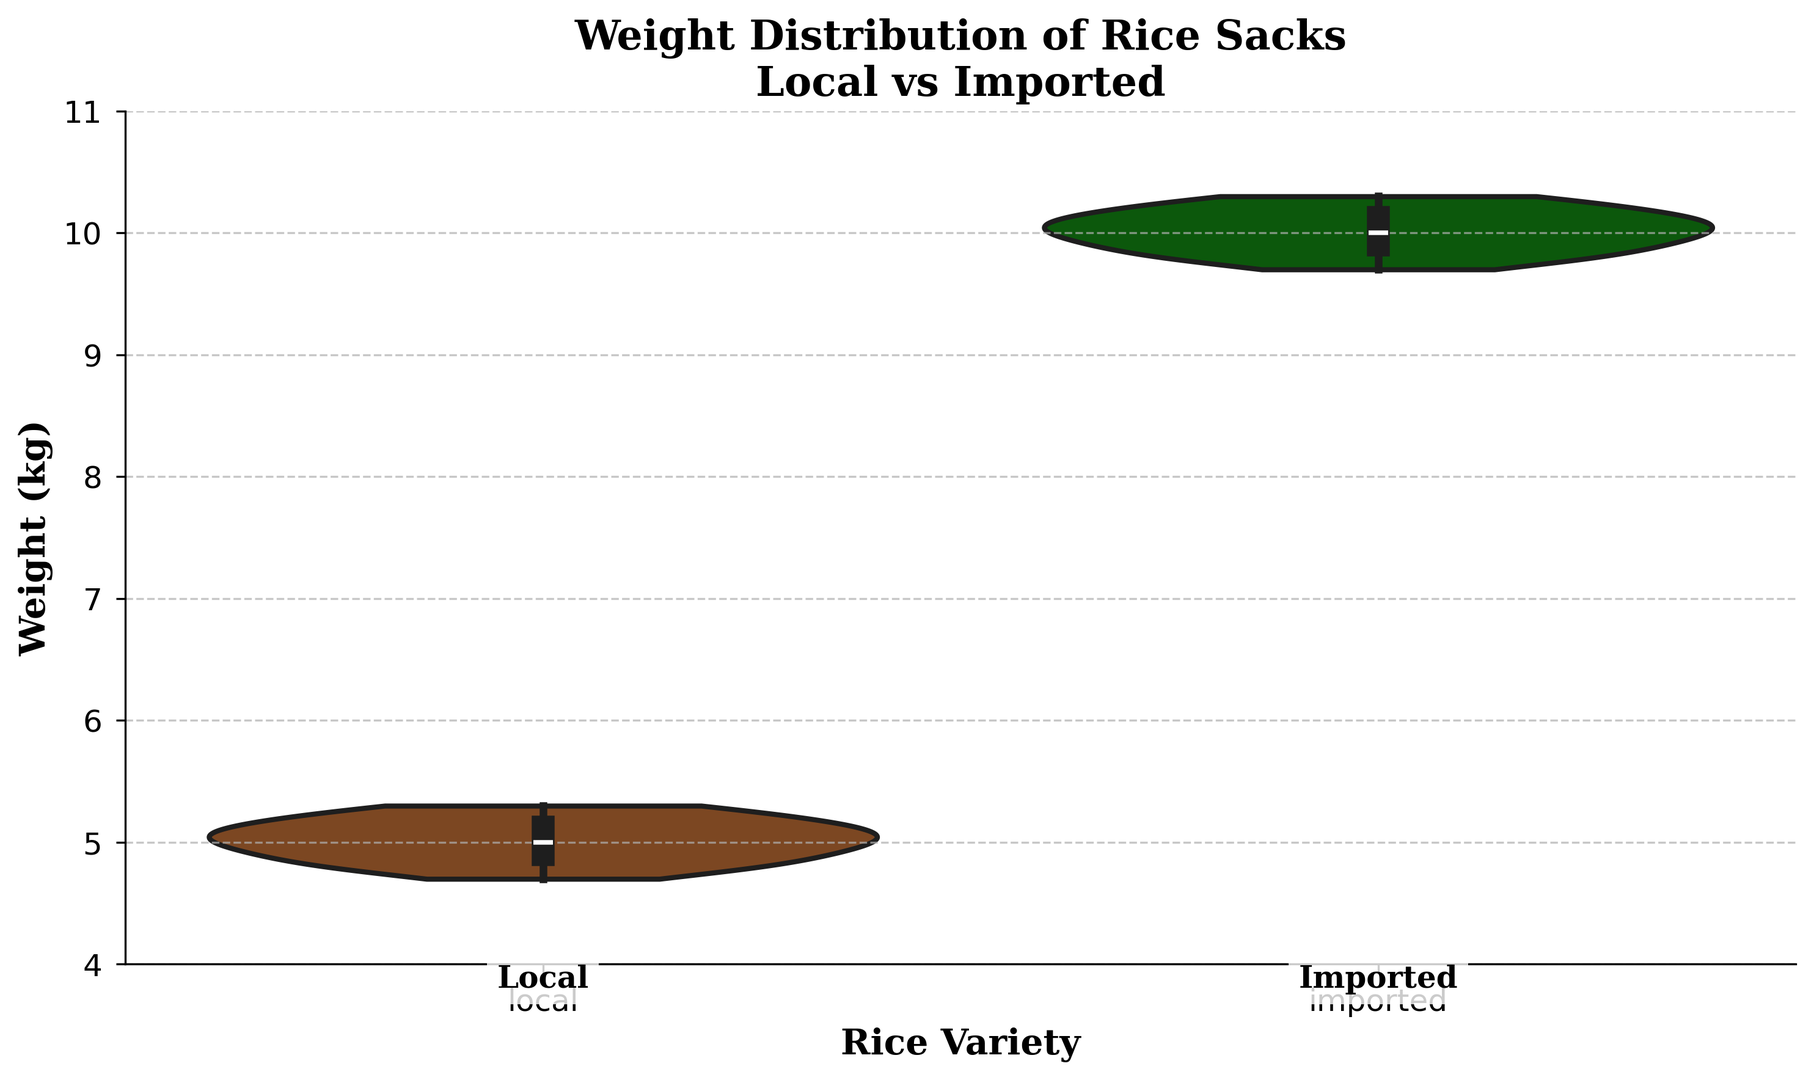What is the general outline shape for local rice weight distribution? The violin plot for local rice weight distribution shows the density of data points across different weight values. The local variety seems to have a single peak around 5 kg, suggesting most weights are concentrated around this value. The distribution tapers off on both sides.
Answer: Single peak around 5 kg and tapers off on both sides Which rice variety has a higher median weight? The violin plot includes a box plot inside each violin. The median is represented by the white dot in the middle of the box plot. For local rice, the median weight is around 5 kg, whereas for imported rice, it is around 10 kg.
Answer: Imported Are the weight distributions of the two rice varieties overlapping? The plot shows the weight distributions in separate violins. The local variety ranges from 4.7 to 5.3 kg, while the imported variety ranges from 9.7 to 10.3 kg. There is no overlap between these ranges.
Answer: No Comparing the spans of the distributions, which variety has a wider range? The local rice distribution ranges from 4.7 to 5.3 kg (a span of 0.6 kg), while the imported rice distribution ranges from 9.7 to 10.3 kg (also a span of 0.6 kg). Both have the same range.
Answer: Same range (0.6 kg) Which variety shows a greater variability in weight? Variability can be observed by the width and spread of the violin plot. Both distributions seem quite tight without much spread, suggesting low variability. Given the symmetrical shapes and narrow range, both show similar low variability.
Answer: Similar low variability What is the main visual difference between the two plots? The main visual difference between the two violins is the location of the peaks. The local rice has a peak around 5 kg, while the imported rice has a peak around 10 kg.
Answer: Location of peaks What would you infer about the consistency of the rice varieties based on the plots? Since the plots for both varieties are tightly clustered around their respective peaks, this suggests that both local and imported rice weights are consistent and do not vary widely.
Answer: High consistency 